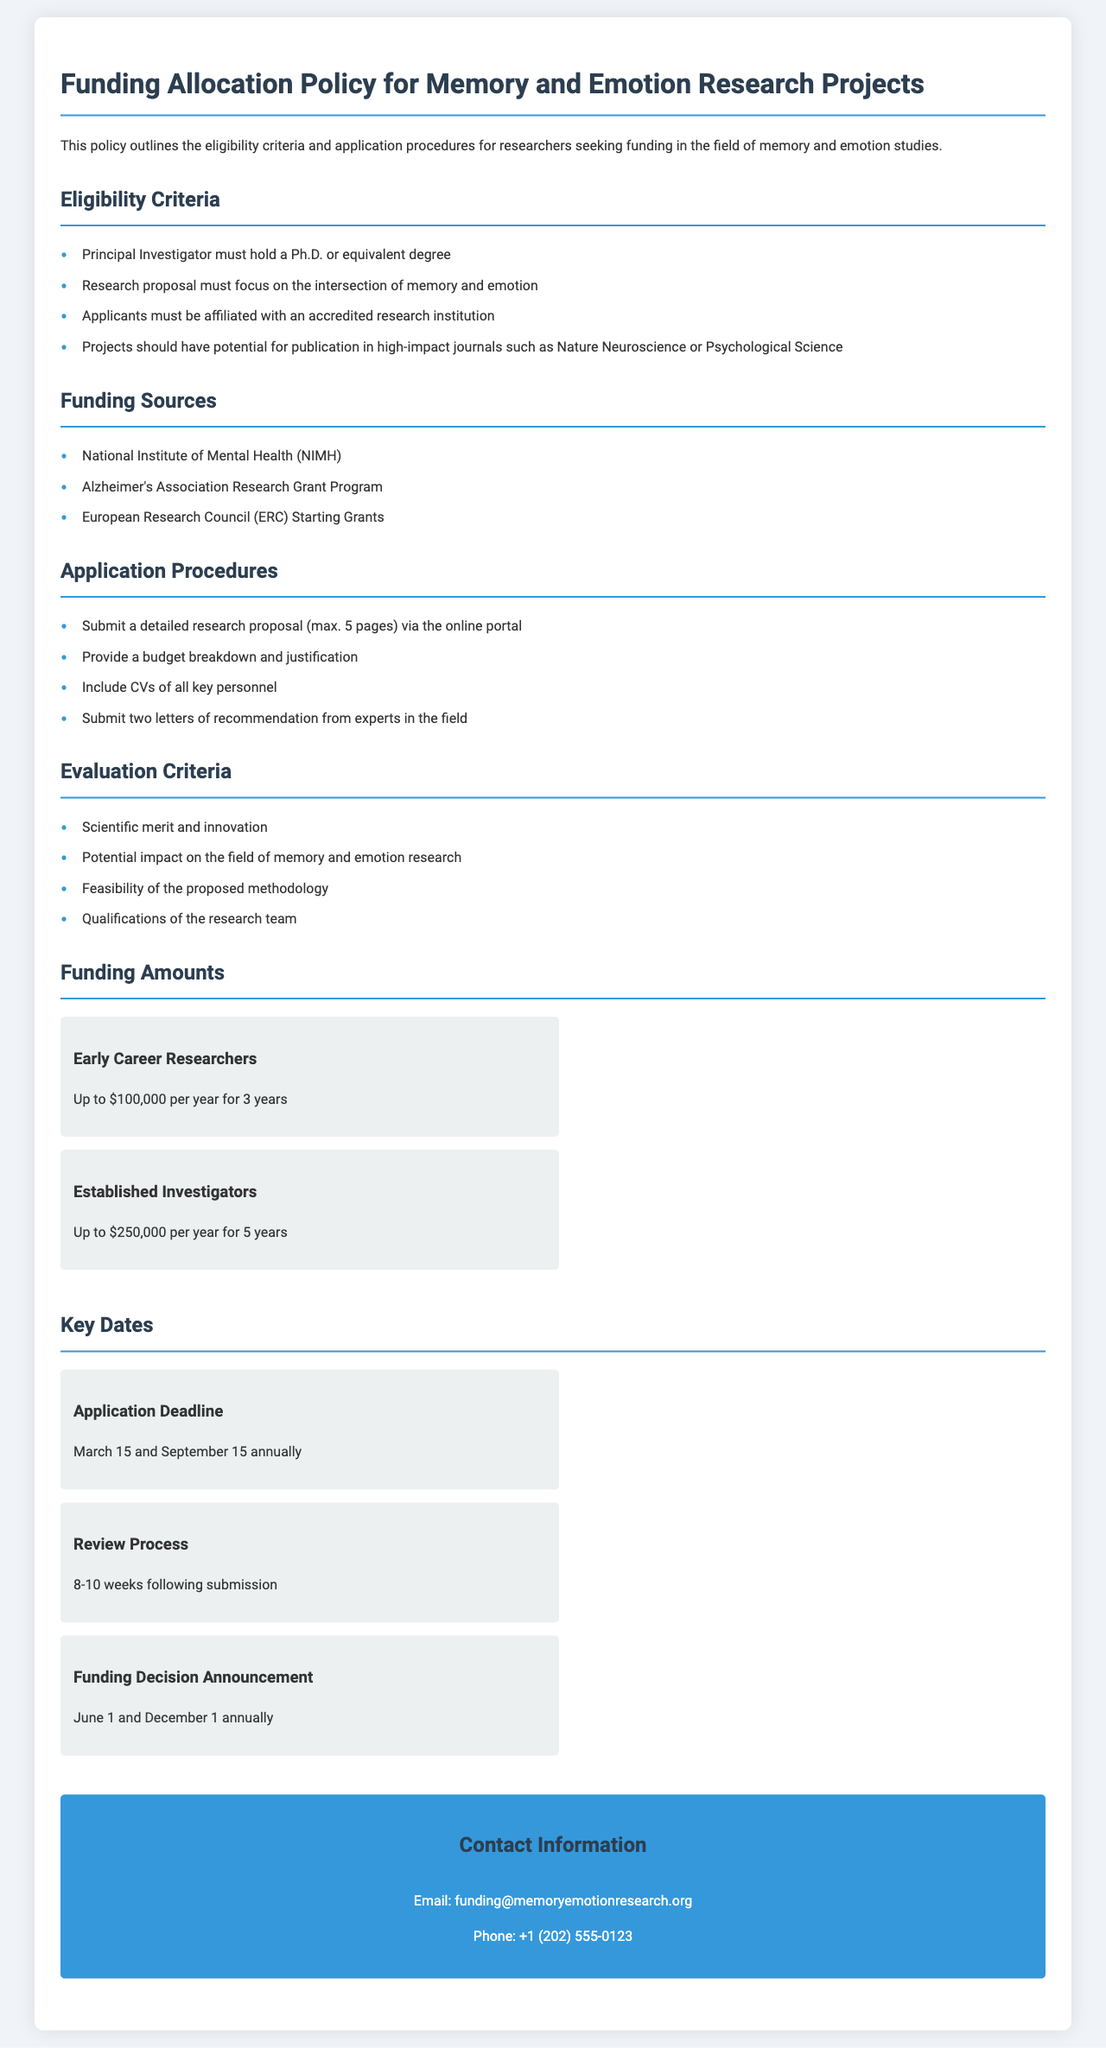What is the maximum funding amount for Early Career Researchers? The document states that Early Career Researchers can receive up to $100,000 per year for 3 years.
Answer: Up to $100,000 per year for 3 years Who must hold a Ph.D. or equivalent degree? According to the eligibility criteria, the Principal Investigator must hold a Ph.D. or equivalent degree.
Answer: Principal Investigator What is the application deadline? The key dates section of the document mentions two application deadlines: March 15 and September 15 annually.
Answer: March 15 and September 15 annually How many letters of recommendation need to be submitted? The application procedures clearly state that two letters of recommendation from experts in the field must be submitted.
Answer: Two letters What are the funding sources listed in the document? The document lists three funding sources, specifically the National Institute of Mental Health (NIMH), Alzheimer's Association Research Grant Program, and European Research Council (ERC) Starting Grants.
Answer: National Institute of Mental Health (NIMH), Alzheimer's Association Research Grant Program, European Research Council (ERC) Starting Grants What is the review process duration after submission? The document states that the review process takes 8-10 weeks following submission.
Answer: 8-10 weeks What is one of the evaluation criteria for research proposals? The evaluation criteria section outlines various criteria, including scientific merit and innovation as a key assessment factor.
Answer: Scientific merit and innovation What is the email address for contact information? The contact information section provides an email contact for inquiries related to funding.
Answer: funding@memoryemotionresearch.org 